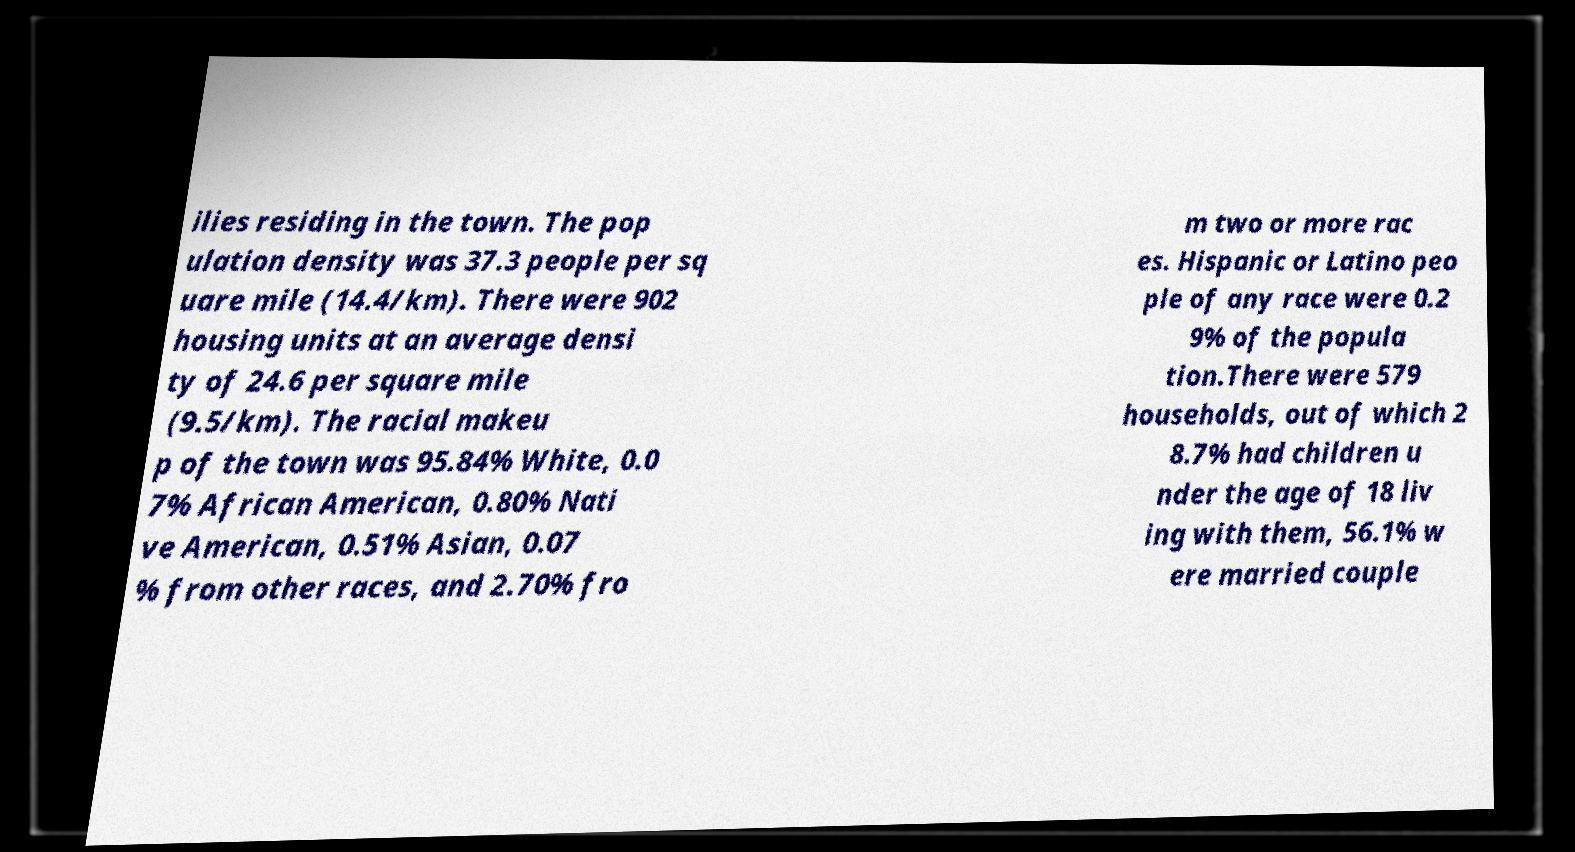For documentation purposes, I need the text within this image transcribed. Could you provide that? ilies residing in the town. The pop ulation density was 37.3 people per sq uare mile (14.4/km). There were 902 housing units at an average densi ty of 24.6 per square mile (9.5/km). The racial makeu p of the town was 95.84% White, 0.0 7% African American, 0.80% Nati ve American, 0.51% Asian, 0.07 % from other races, and 2.70% fro m two or more rac es. Hispanic or Latino peo ple of any race were 0.2 9% of the popula tion.There were 579 households, out of which 2 8.7% had children u nder the age of 18 liv ing with them, 56.1% w ere married couple 